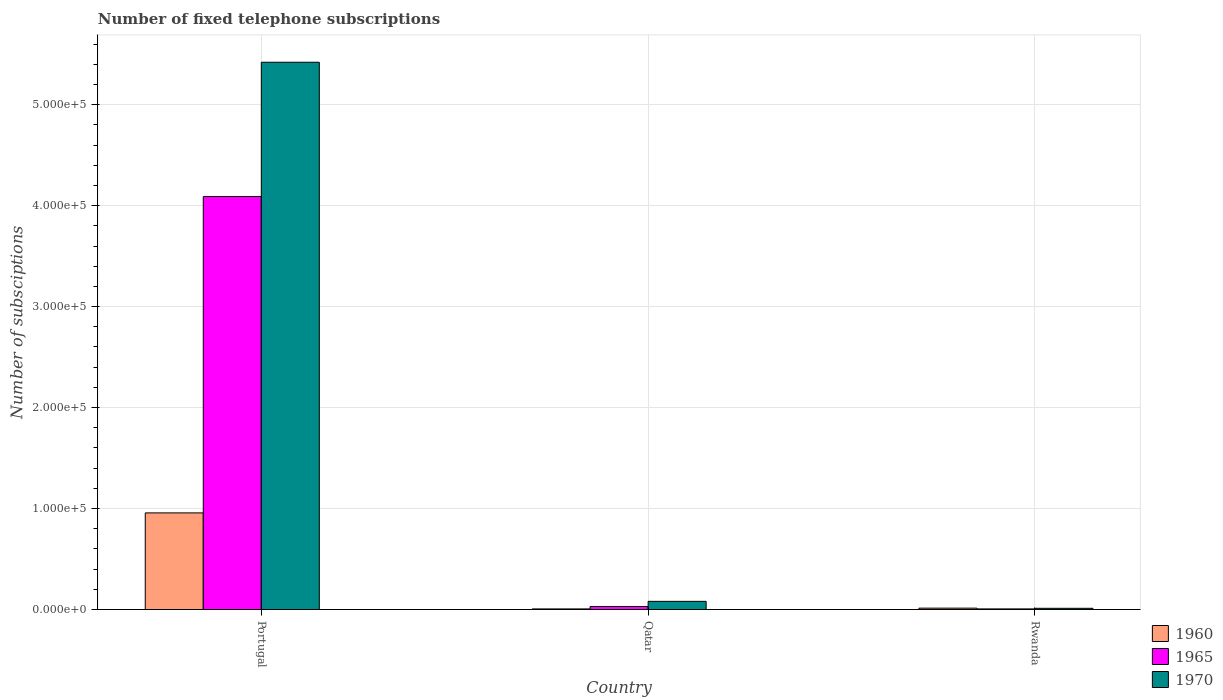Are the number of bars per tick equal to the number of legend labels?
Your response must be concise. Yes. Are the number of bars on each tick of the X-axis equal?
Make the answer very short. Yes. How many bars are there on the 3rd tick from the left?
Your answer should be very brief. 3. How many bars are there on the 1st tick from the right?
Give a very brief answer. 3. What is the label of the 2nd group of bars from the left?
Your answer should be compact. Qatar. In how many cases, is the number of bars for a given country not equal to the number of legend labels?
Make the answer very short. 0. What is the number of fixed telephone subscriptions in 1965 in Portugal?
Offer a very short reply. 4.09e+05. Across all countries, what is the maximum number of fixed telephone subscriptions in 1965?
Provide a short and direct response. 4.09e+05. Across all countries, what is the minimum number of fixed telephone subscriptions in 1965?
Provide a short and direct response. 600. In which country was the number of fixed telephone subscriptions in 1960 maximum?
Your answer should be compact. Portugal. In which country was the number of fixed telephone subscriptions in 1970 minimum?
Your answer should be compact. Rwanda. What is the total number of fixed telephone subscriptions in 1960 in the graph?
Offer a very short reply. 9.77e+04. What is the difference between the number of fixed telephone subscriptions in 1970 in Portugal and that in Qatar?
Make the answer very short. 5.34e+05. What is the difference between the number of fixed telephone subscriptions in 1965 in Portugal and the number of fixed telephone subscriptions in 1970 in Qatar?
Give a very brief answer. 4.01e+05. What is the average number of fixed telephone subscriptions in 1960 per country?
Your answer should be compact. 3.26e+04. What is the difference between the number of fixed telephone subscriptions of/in 1970 and number of fixed telephone subscriptions of/in 1960 in Rwanda?
Offer a very short reply. -166. In how many countries, is the number of fixed telephone subscriptions in 1970 greater than 120000?
Make the answer very short. 1. What is the ratio of the number of fixed telephone subscriptions in 1960 in Portugal to that in Rwanda?
Make the answer very short. 70.06. Is the difference between the number of fixed telephone subscriptions in 1970 in Qatar and Rwanda greater than the difference between the number of fixed telephone subscriptions in 1960 in Qatar and Rwanda?
Make the answer very short. Yes. What is the difference between the highest and the second highest number of fixed telephone subscriptions in 1965?
Your response must be concise. 4.08e+05. What is the difference between the highest and the lowest number of fixed telephone subscriptions in 1960?
Your response must be concise. 9.51e+04. In how many countries, is the number of fixed telephone subscriptions in 1960 greater than the average number of fixed telephone subscriptions in 1960 taken over all countries?
Keep it short and to the point. 1. Is the sum of the number of fixed telephone subscriptions in 1960 in Portugal and Qatar greater than the maximum number of fixed telephone subscriptions in 1970 across all countries?
Your response must be concise. No. What does the 3rd bar from the right in Rwanda represents?
Provide a succinct answer. 1960. How many bars are there?
Your answer should be very brief. 9. Are all the bars in the graph horizontal?
Offer a terse response. No. How many countries are there in the graph?
Provide a succinct answer. 3. Are the values on the major ticks of Y-axis written in scientific E-notation?
Offer a very short reply. Yes. Does the graph contain grids?
Ensure brevity in your answer.  Yes. Where does the legend appear in the graph?
Your answer should be very brief. Bottom right. How many legend labels are there?
Your answer should be very brief. 3. How are the legend labels stacked?
Ensure brevity in your answer.  Vertical. What is the title of the graph?
Keep it short and to the point. Number of fixed telephone subscriptions. What is the label or title of the X-axis?
Provide a succinct answer. Country. What is the label or title of the Y-axis?
Ensure brevity in your answer.  Number of subsciptions. What is the Number of subsciptions of 1960 in Portugal?
Keep it short and to the point. 9.57e+04. What is the Number of subsciptions of 1965 in Portugal?
Your answer should be very brief. 4.09e+05. What is the Number of subsciptions in 1970 in Portugal?
Ensure brevity in your answer.  5.42e+05. What is the Number of subsciptions of 1960 in Qatar?
Provide a short and direct response. 600. What is the Number of subsciptions of 1965 in Qatar?
Keep it short and to the point. 3000. What is the Number of subsciptions in 1970 in Qatar?
Provide a short and direct response. 8100. What is the Number of subsciptions in 1960 in Rwanda?
Your answer should be very brief. 1366. What is the Number of subsciptions in 1965 in Rwanda?
Your response must be concise. 600. What is the Number of subsciptions of 1970 in Rwanda?
Offer a terse response. 1200. Across all countries, what is the maximum Number of subsciptions of 1960?
Your answer should be very brief. 9.57e+04. Across all countries, what is the maximum Number of subsciptions in 1965?
Keep it short and to the point. 4.09e+05. Across all countries, what is the maximum Number of subsciptions in 1970?
Provide a succinct answer. 5.42e+05. Across all countries, what is the minimum Number of subsciptions in 1960?
Offer a very short reply. 600. Across all countries, what is the minimum Number of subsciptions of 1965?
Keep it short and to the point. 600. Across all countries, what is the minimum Number of subsciptions of 1970?
Offer a terse response. 1200. What is the total Number of subsciptions of 1960 in the graph?
Make the answer very short. 9.77e+04. What is the total Number of subsciptions of 1965 in the graph?
Make the answer very short. 4.13e+05. What is the total Number of subsciptions in 1970 in the graph?
Keep it short and to the point. 5.51e+05. What is the difference between the Number of subsciptions of 1960 in Portugal and that in Qatar?
Provide a short and direct response. 9.51e+04. What is the difference between the Number of subsciptions in 1965 in Portugal and that in Qatar?
Your answer should be very brief. 4.06e+05. What is the difference between the Number of subsciptions in 1970 in Portugal and that in Qatar?
Offer a terse response. 5.34e+05. What is the difference between the Number of subsciptions in 1960 in Portugal and that in Rwanda?
Ensure brevity in your answer.  9.43e+04. What is the difference between the Number of subsciptions of 1965 in Portugal and that in Rwanda?
Keep it short and to the point. 4.08e+05. What is the difference between the Number of subsciptions of 1970 in Portugal and that in Rwanda?
Offer a terse response. 5.41e+05. What is the difference between the Number of subsciptions in 1960 in Qatar and that in Rwanda?
Your answer should be compact. -766. What is the difference between the Number of subsciptions in 1965 in Qatar and that in Rwanda?
Provide a succinct answer. 2400. What is the difference between the Number of subsciptions of 1970 in Qatar and that in Rwanda?
Offer a terse response. 6900. What is the difference between the Number of subsciptions of 1960 in Portugal and the Number of subsciptions of 1965 in Qatar?
Offer a very short reply. 9.27e+04. What is the difference between the Number of subsciptions in 1960 in Portugal and the Number of subsciptions in 1970 in Qatar?
Provide a succinct answer. 8.76e+04. What is the difference between the Number of subsciptions of 1965 in Portugal and the Number of subsciptions of 1970 in Qatar?
Ensure brevity in your answer.  4.01e+05. What is the difference between the Number of subsciptions in 1960 in Portugal and the Number of subsciptions in 1965 in Rwanda?
Offer a terse response. 9.51e+04. What is the difference between the Number of subsciptions of 1960 in Portugal and the Number of subsciptions of 1970 in Rwanda?
Give a very brief answer. 9.45e+04. What is the difference between the Number of subsciptions in 1965 in Portugal and the Number of subsciptions in 1970 in Rwanda?
Offer a terse response. 4.08e+05. What is the difference between the Number of subsciptions in 1960 in Qatar and the Number of subsciptions in 1965 in Rwanda?
Your answer should be very brief. 0. What is the difference between the Number of subsciptions in 1960 in Qatar and the Number of subsciptions in 1970 in Rwanda?
Keep it short and to the point. -600. What is the difference between the Number of subsciptions in 1965 in Qatar and the Number of subsciptions in 1970 in Rwanda?
Your response must be concise. 1800. What is the average Number of subsciptions in 1960 per country?
Offer a very short reply. 3.26e+04. What is the average Number of subsciptions of 1965 per country?
Ensure brevity in your answer.  1.38e+05. What is the average Number of subsciptions of 1970 per country?
Offer a terse response. 1.84e+05. What is the difference between the Number of subsciptions of 1960 and Number of subsciptions of 1965 in Portugal?
Keep it short and to the point. -3.13e+05. What is the difference between the Number of subsciptions in 1960 and Number of subsciptions in 1970 in Portugal?
Keep it short and to the point. -4.46e+05. What is the difference between the Number of subsciptions of 1965 and Number of subsciptions of 1970 in Portugal?
Provide a short and direct response. -1.33e+05. What is the difference between the Number of subsciptions of 1960 and Number of subsciptions of 1965 in Qatar?
Make the answer very short. -2400. What is the difference between the Number of subsciptions of 1960 and Number of subsciptions of 1970 in Qatar?
Your answer should be compact. -7500. What is the difference between the Number of subsciptions in 1965 and Number of subsciptions in 1970 in Qatar?
Make the answer very short. -5100. What is the difference between the Number of subsciptions of 1960 and Number of subsciptions of 1965 in Rwanda?
Keep it short and to the point. 766. What is the difference between the Number of subsciptions of 1960 and Number of subsciptions of 1970 in Rwanda?
Give a very brief answer. 166. What is the difference between the Number of subsciptions of 1965 and Number of subsciptions of 1970 in Rwanda?
Offer a terse response. -600. What is the ratio of the Number of subsciptions of 1960 in Portugal to that in Qatar?
Give a very brief answer. 159.5. What is the ratio of the Number of subsciptions in 1965 in Portugal to that in Qatar?
Your answer should be compact. 136.33. What is the ratio of the Number of subsciptions of 1970 in Portugal to that in Qatar?
Keep it short and to the point. 66.91. What is the ratio of the Number of subsciptions of 1960 in Portugal to that in Rwanda?
Your response must be concise. 70.06. What is the ratio of the Number of subsciptions in 1965 in Portugal to that in Rwanda?
Make the answer very short. 681.67. What is the ratio of the Number of subsciptions in 1970 in Portugal to that in Rwanda?
Offer a very short reply. 451.67. What is the ratio of the Number of subsciptions in 1960 in Qatar to that in Rwanda?
Make the answer very short. 0.44. What is the ratio of the Number of subsciptions of 1970 in Qatar to that in Rwanda?
Make the answer very short. 6.75. What is the difference between the highest and the second highest Number of subsciptions of 1960?
Make the answer very short. 9.43e+04. What is the difference between the highest and the second highest Number of subsciptions in 1965?
Keep it short and to the point. 4.06e+05. What is the difference between the highest and the second highest Number of subsciptions of 1970?
Ensure brevity in your answer.  5.34e+05. What is the difference between the highest and the lowest Number of subsciptions of 1960?
Offer a terse response. 9.51e+04. What is the difference between the highest and the lowest Number of subsciptions of 1965?
Make the answer very short. 4.08e+05. What is the difference between the highest and the lowest Number of subsciptions of 1970?
Make the answer very short. 5.41e+05. 